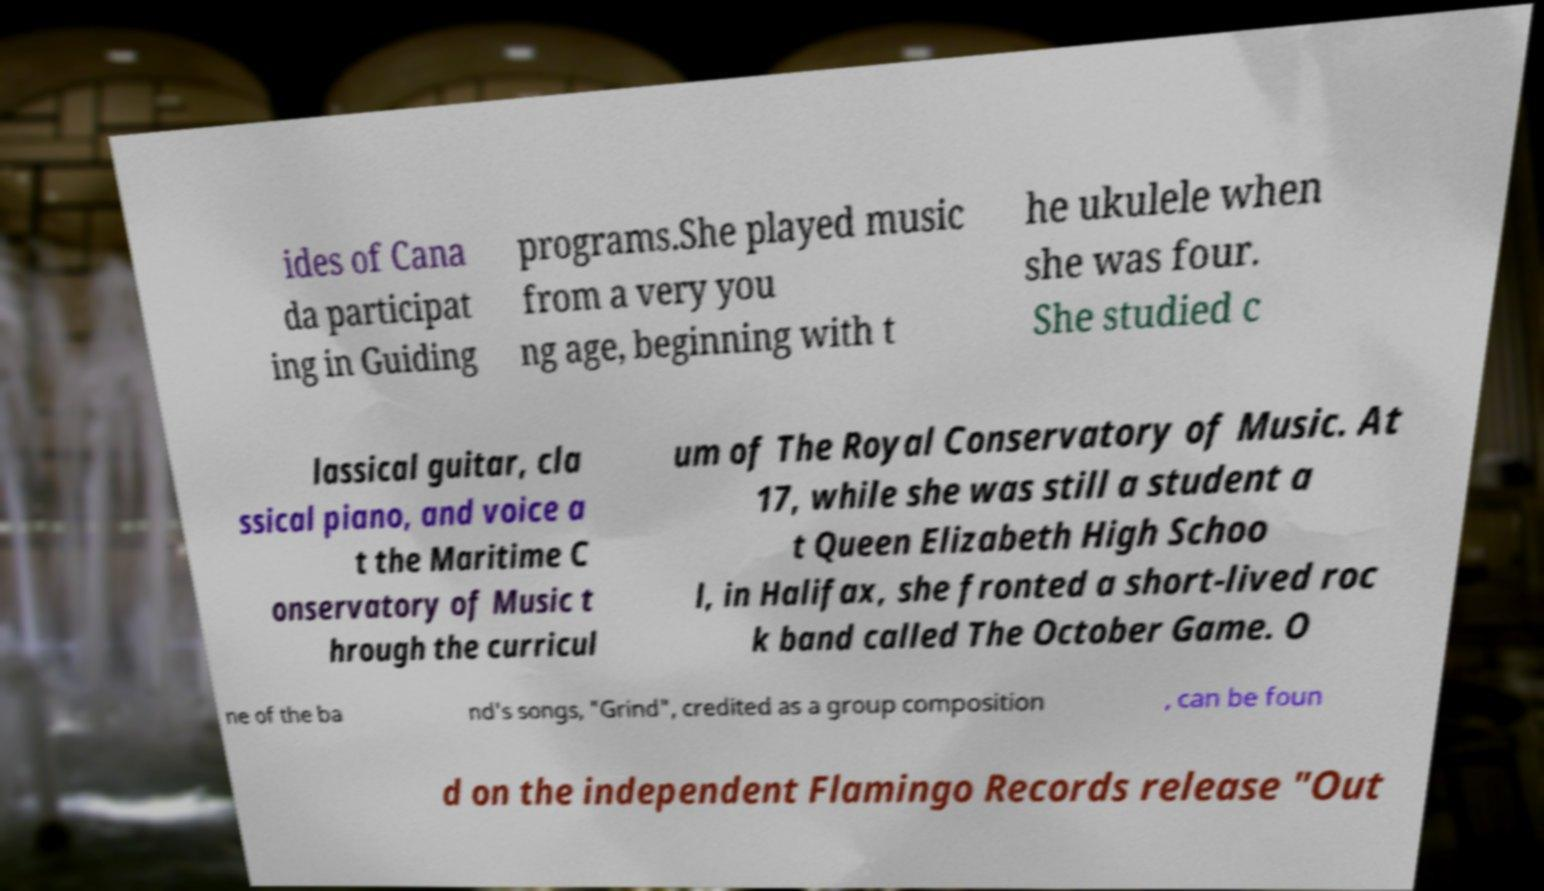Can you read and provide the text displayed in the image?This photo seems to have some interesting text. Can you extract and type it out for me? ides of Cana da participat ing in Guiding programs.She played music from a very you ng age, beginning with t he ukulele when she was four. She studied c lassical guitar, cla ssical piano, and voice a t the Maritime C onservatory of Music t hrough the curricul um of The Royal Conservatory of Music. At 17, while she was still a student a t Queen Elizabeth High Schoo l, in Halifax, she fronted a short-lived roc k band called The October Game. O ne of the ba nd's songs, "Grind", credited as a group composition , can be foun d on the independent Flamingo Records release "Out 